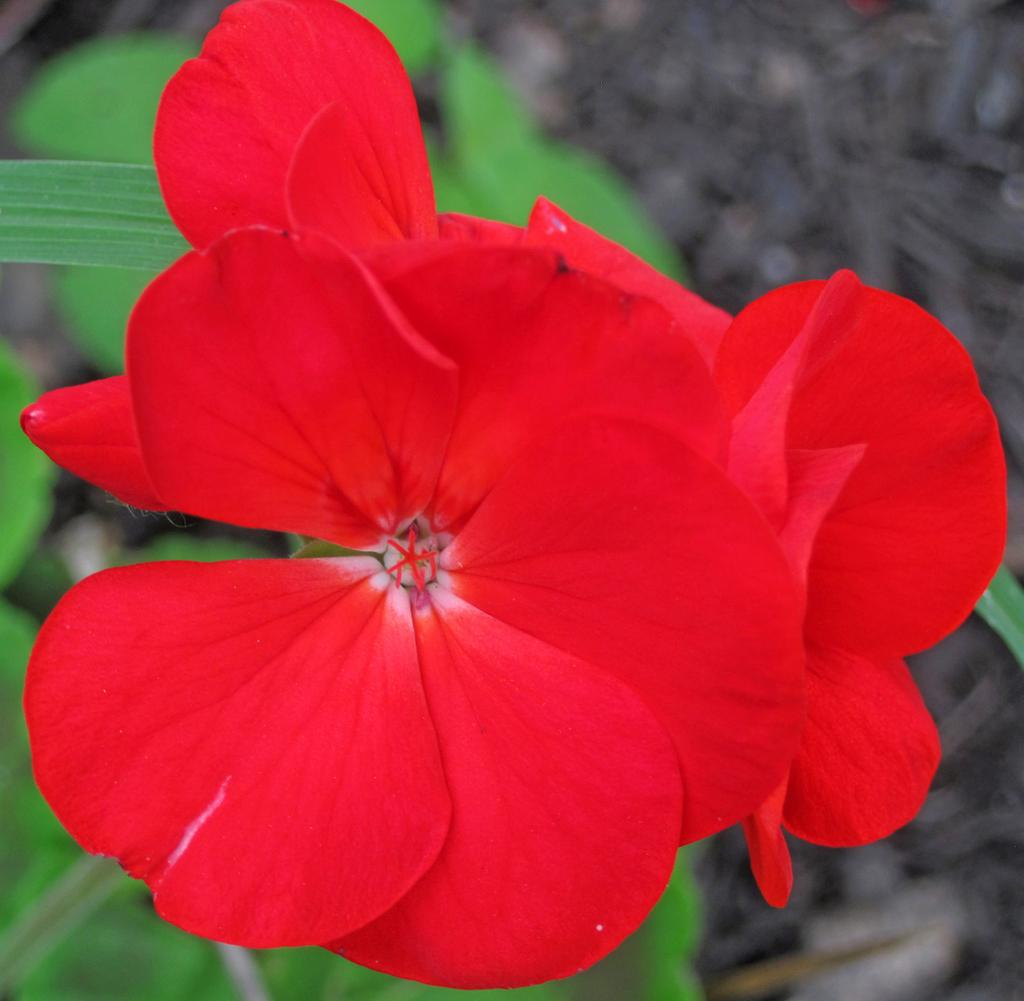What type of flowers can be seen in the image? There are red flowers in the image. What else is present on the flowers? There are leaves in the image. How would you describe the background of the image? The background of the image has a blurred view. What color is associated with the leaves and flowers in the image? The color green is present in the image. What type of destruction can be seen happening to the flowers in the image? There is no destruction present in the image; the flowers appear intact. How many nails are visible in the image? There are no nails present in the image. 